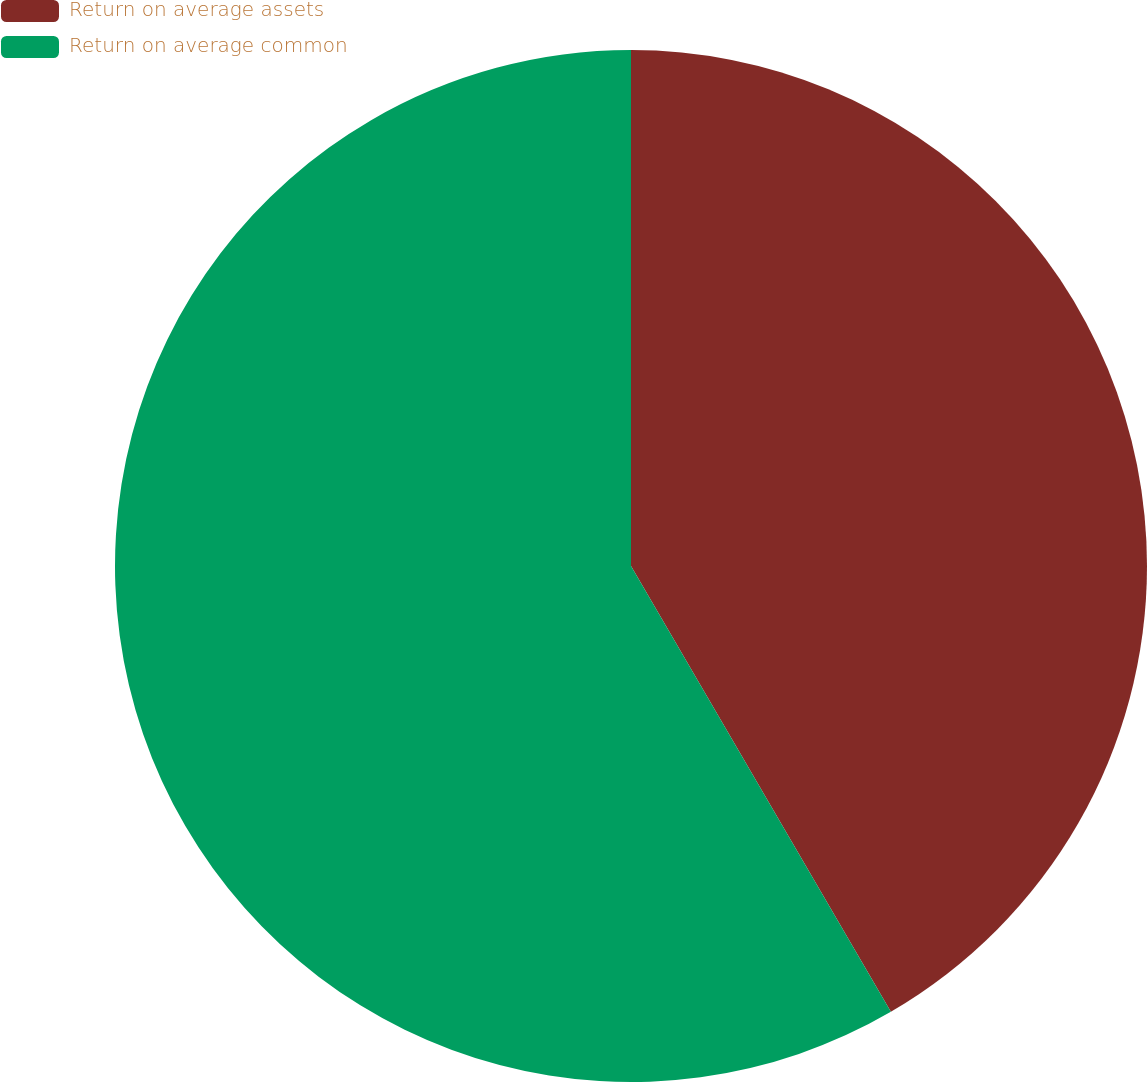Convert chart to OTSL. <chart><loc_0><loc_0><loc_500><loc_500><pie_chart><fcel>Return on average assets<fcel>Return on average common<nl><fcel>41.6%<fcel>58.4%<nl></chart> 